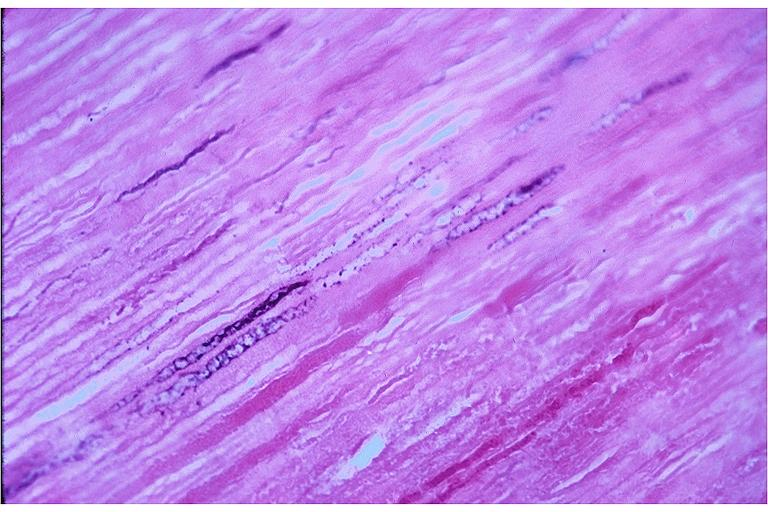s aspiration present?
Answer the question using a single word or phrase. No 